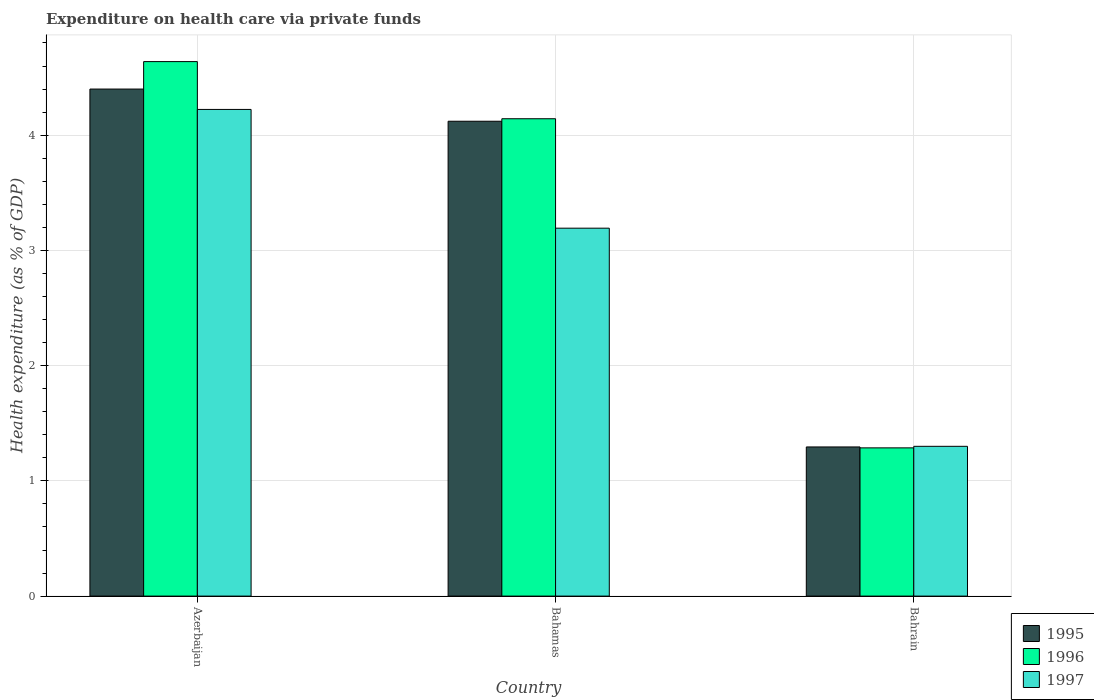How many different coloured bars are there?
Offer a very short reply. 3. Are the number of bars on each tick of the X-axis equal?
Offer a terse response. Yes. What is the label of the 3rd group of bars from the left?
Provide a short and direct response. Bahrain. What is the expenditure made on health care in 1996 in Bahamas?
Offer a terse response. 4.14. Across all countries, what is the maximum expenditure made on health care in 1995?
Provide a succinct answer. 4.4. Across all countries, what is the minimum expenditure made on health care in 1997?
Offer a very short reply. 1.3. In which country was the expenditure made on health care in 1995 maximum?
Provide a short and direct response. Azerbaijan. In which country was the expenditure made on health care in 1997 minimum?
Give a very brief answer. Bahrain. What is the total expenditure made on health care in 1996 in the graph?
Offer a terse response. 10.07. What is the difference between the expenditure made on health care in 1997 in Azerbaijan and that in Bahrain?
Your response must be concise. 2.92. What is the difference between the expenditure made on health care in 1996 in Bahamas and the expenditure made on health care in 1997 in Bahrain?
Keep it short and to the point. 2.84. What is the average expenditure made on health care in 1995 per country?
Offer a very short reply. 3.27. What is the difference between the expenditure made on health care of/in 1996 and expenditure made on health care of/in 1997 in Bahrain?
Your answer should be very brief. -0.01. What is the ratio of the expenditure made on health care in 1996 in Azerbaijan to that in Bahamas?
Your answer should be compact. 1.12. What is the difference between the highest and the second highest expenditure made on health care in 1997?
Provide a short and direct response. -1.89. What is the difference between the highest and the lowest expenditure made on health care in 1996?
Give a very brief answer. 3.35. In how many countries, is the expenditure made on health care in 1997 greater than the average expenditure made on health care in 1997 taken over all countries?
Ensure brevity in your answer.  2. What does the 3rd bar from the left in Bahamas represents?
Your answer should be compact. 1997. What does the 2nd bar from the right in Azerbaijan represents?
Ensure brevity in your answer.  1996. Are all the bars in the graph horizontal?
Ensure brevity in your answer.  No. What is the difference between two consecutive major ticks on the Y-axis?
Offer a terse response. 1. Are the values on the major ticks of Y-axis written in scientific E-notation?
Your answer should be very brief. No. Does the graph contain grids?
Your answer should be compact. Yes. Where does the legend appear in the graph?
Keep it short and to the point. Bottom right. How many legend labels are there?
Your answer should be very brief. 3. How are the legend labels stacked?
Give a very brief answer. Vertical. What is the title of the graph?
Provide a succinct answer. Expenditure on health care via private funds. Does "1961" appear as one of the legend labels in the graph?
Your response must be concise. No. What is the label or title of the Y-axis?
Give a very brief answer. Health expenditure (as % of GDP). What is the Health expenditure (as % of GDP) of 1995 in Azerbaijan?
Your answer should be compact. 4.4. What is the Health expenditure (as % of GDP) in 1996 in Azerbaijan?
Provide a short and direct response. 4.64. What is the Health expenditure (as % of GDP) in 1997 in Azerbaijan?
Offer a terse response. 4.22. What is the Health expenditure (as % of GDP) of 1995 in Bahamas?
Give a very brief answer. 4.12. What is the Health expenditure (as % of GDP) in 1996 in Bahamas?
Your answer should be compact. 4.14. What is the Health expenditure (as % of GDP) of 1997 in Bahamas?
Offer a very short reply. 3.19. What is the Health expenditure (as % of GDP) of 1995 in Bahrain?
Give a very brief answer. 1.29. What is the Health expenditure (as % of GDP) of 1996 in Bahrain?
Give a very brief answer. 1.29. What is the Health expenditure (as % of GDP) of 1997 in Bahrain?
Offer a terse response. 1.3. Across all countries, what is the maximum Health expenditure (as % of GDP) in 1995?
Offer a terse response. 4.4. Across all countries, what is the maximum Health expenditure (as % of GDP) of 1996?
Provide a succinct answer. 4.64. Across all countries, what is the maximum Health expenditure (as % of GDP) of 1997?
Keep it short and to the point. 4.22. Across all countries, what is the minimum Health expenditure (as % of GDP) in 1995?
Your answer should be compact. 1.29. Across all countries, what is the minimum Health expenditure (as % of GDP) of 1996?
Provide a succinct answer. 1.29. Across all countries, what is the minimum Health expenditure (as % of GDP) of 1997?
Your response must be concise. 1.3. What is the total Health expenditure (as % of GDP) in 1995 in the graph?
Give a very brief answer. 9.82. What is the total Health expenditure (as % of GDP) in 1996 in the graph?
Offer a very short reply. 10.07. What is the total Health expenditure (as % of GDP) of 1997 in the graph?
Your answer should be compact. 8.72. What is the difference between the Health expenditure (as % of GDP) of 1995 in Azerbaijan and that in Bahamas?
Provide a succinct answer. 0.28. What is the difference between the Health expenditure (as % of GDP) of 1996 in Azerbaijan and that in Bahamas?
Your answer should be very brief. 0.5. What is the difference between the Health expenditure (as % of GDP) in 1997 in Azerbaijan and that in Bahamas?
Make the answer very short. 1.03. What is the difference between the Health expenditure (as % of GDP) in 1995 in Azerbaijan and that in Bahrain?
Your response must be concise. 3.11. What is the difference between the Health expenditure (as % of GDP) in 1996 in Azerbaijan and that in Bahrain?
Provide a succinct answer. 3.35. What is the difference between the Health expenditure (as % of GDP) of 1997 in Azerbaijan and that in Bahrain?
Offer a terse response. 2.92. What is the difference between the Health expenditure (as % of GDP) of 1995 in Bahamas and that in Bahrain?
Your response must be concise. 2.83. What is the difference between the Health expenditure (as % of GDP) in 1996 in Bahamas and that in Bahrain?
Ensure brevity in your answer.  2.86. What is the difference between the Health expenditure (as % of GDP) of 1997 in Bahamas and that in Bahrain?
Keep it short and to the point. 1.89. What is the difference between the Health expenditure (as % of GDP) of 1995 in Azerbaijan and the Health expenditure (as % of GDP) of 1996 in Bahamas?
Your answer should be compact. 0.26. What is the difference between the Health expenditure (as % of GDP) in 1995 in Azerbaijan and the Health expenditure (as % of GDP) in 1997 in Bahamas?
Provide a succinct answer. 1.21. What is the difference between the Health expenditure (as % of GDP) of 1996 in Azerbaijan and the Health expenditure (as % of GDP) of 1997 in Bahamas?
Provide a short and direct response. 1.45. What is the difference between the Health expenditure (as % of GDP) in 1995 in Azerbaijan and the Health expenditure (as % of GDP) in 1996 in Bahrain?
Your response must be concise. 3.11. What is the difference between the Health expenditure (as % of GDP) of 1995 in Azerbaijan and the Health expenditure (as % of GDP) of 1997 in Bahrain?
Provide a succinct answer. 3.1. What is the difference between the Health expenditure (as % of GDP) in 1996 in Azerbaijan and the Health expenditure (as % of GDP) in 1997 in Bahrain?
Your response must be concise. 3.34. What is the difference between the Health expenditure (as % of GDP) of 1995 in Bahamas and the Health expenditure (as % of GDP) of 1996 in Bahrain?
Keep it short and to the point. 2.83. What is the difference between the Health expenditure (as % of GDP) in 1995 in Bahamas and the Health expenditure (as % of GDP) in 1997 in Bahrain?
Your answer should be very brief. 2.82. What is the difference between the Health expenditure (as % of GDP) in 1996 in Bahamas and the Health expenditure (as % of GDP) in 1997 in Bahrain?
Keep it short and to the point. 2.84. What is the average Health expenditure (as % of GDP) in 1995 per country?
Ensure brevity in your answer.  3.27. What is the average Health expenditure (as % of GDP) of 1996 per country?
Offer a very short reply. 3.36. What is the average Health expenditure (as % of GDP) in 1997 per country?
Offer a terse response. 2.91. What is the difference between the Health expenditure (as % of GDP) of 1995 and Health expenditure (as % of GDP) of 1996 in Azerbaijan?
Provide a succinct answer. -0.24. What is the difference between the Health expenditure (as % of GDP) in 1995 and Health expenditure (as % of GDP) in 1997 in Azerbaijan?
Provide a succinct answer. 0.18. What is the difference between the Health expenditure (as % of GDP) of 1996 and Health expenditure (as % of GDP) of 1997 in Azerbaijan?
Give a very brief answer. 0.41. What is the difference between the Health expenditure (as % of GDP) of 1995 and Health expenditure (as % of GDP) of 1996 in Bahamas?
Your answer should be compact. -0.02. What is the difference between the Health expenditure (as % of GDP) of 1995 and Health expenditure (as % of GDP) of 1997 in Bahamas?
Your answer should be compact. 0.93. What is the difference between the Health expenditure (as % of GDP) in 1996 and Health expenditure (as % of GDP) in 1997 in Bahamas?
Ensure brevity in your answer.  0.95. What is the difference between the Health expenditure (as % of GDP) of 1995 and Health expenditure (as % of GDP) of 1996 in Bahrain?
Your answer should be compact. 0.01. What is the difference between the Health expenditure (as % of GDP) in 1995 and Health expenditure (as % of GDP) in 1997 in Bahrain?
Provide a short and direct response. -0.01. What is the difference between the Health expenditure (as % of GDP) of 1996 and Health expenditure (as % of GDP) of 1997 in Bahrain?
Your answer should be very brief. -0.01. What is the ratio of the Health expenditure (as % of GDP) in 1995 in Azerbaijan to that in Bahamas?
Make the answer very short. 1.07. What is the ratio of the Health expenditure (as % of GDP) of 1996 in Azerbaijan to that in Bahamas?
Make the answer very short. 1.12. What is the ratio of the Health expenditure (as % of GDP) in 1997 in Azerbaijan to that in Bahamas?
Offer a very short reply. 1.32. What is the ratio of the Health expenditure (as % of GDP) of 1995 in Azerbaijan to that in Bahrain?
Give a very brief answer. 3.4. What is the ratio of the Health expenditure (as % of GDP) in 1996 in Azerbaijan to that in Bahrain?
Your response must be concise. 3.61. What is the ratio of the Health expenditure (as % of GDP) in 1997 in Azerbaijan to that in Bahrain?
Keep it short and to the point. 3.25. What is the ratio of the Health expenditure (as % of GDP) in 1995 in Bahamas to that in Bahrain?
Your answer should be compact. 3.18. What is the ratio of the Health expenditure (as % of GDP) in 1996 in Bahamas to that in Bahrain?
Provide a short and direct response. 3.22. What is the ratio of the Health expenditure (as % of GDP) of 1997 in Bahamas to that in Bahrain?
Ensure brevity in your answer.  2.46. What is the difference between the highest and the second highest Health expenditure (as % of GDP) in 1995?
Provide a short and direct response. 0.28. What is the difference between the highest and the second highest Health expenditure (as % of GDP) of 1996?
Offer a terse response. 0.5. What is the difference between the highest and the second highest Health expenditure (as % of GDP) in 1997?
Offer a terse response. 1.03. What is the difference between the highest and the lowest Health expenditure (as % of GDP) of 1995?
Offer a very short reply. 3.11. What is the difference between the highest and the lowest Health expenditure (as % of GDP) in 1996?
Give a very brief answer. 3.35. What is the difference between the highest and the lowest Health expenditure (as % of GDP) of 1997?
Your answer should be compact. 2.92. 